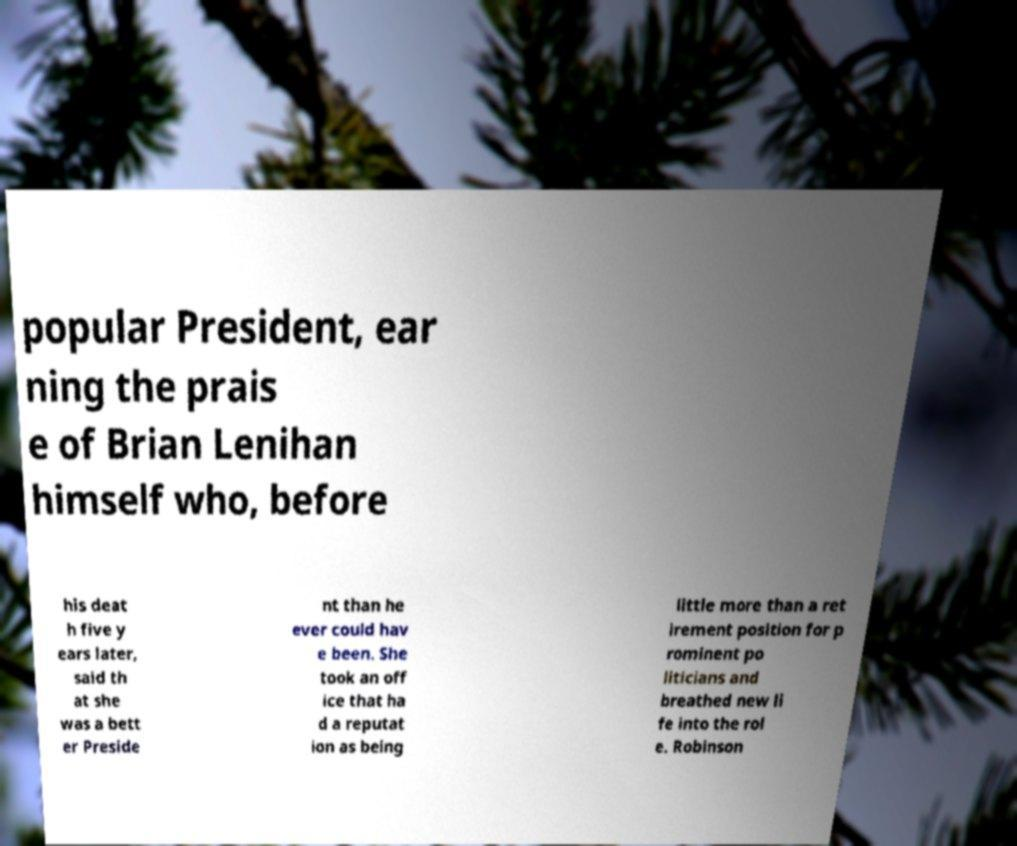Please identify and transcribe the text found in this image. popular President, ear ning the prais e of Brian Lenihan himself who, before his deat h five y ears later, said th at she was a bett er Preside nt than he ever could hav e been. She took an off ice that ha d a reputat ion as being little more than a ret irement position for p rominent po liticians and breathed new li fe into the rol e. Robinson 